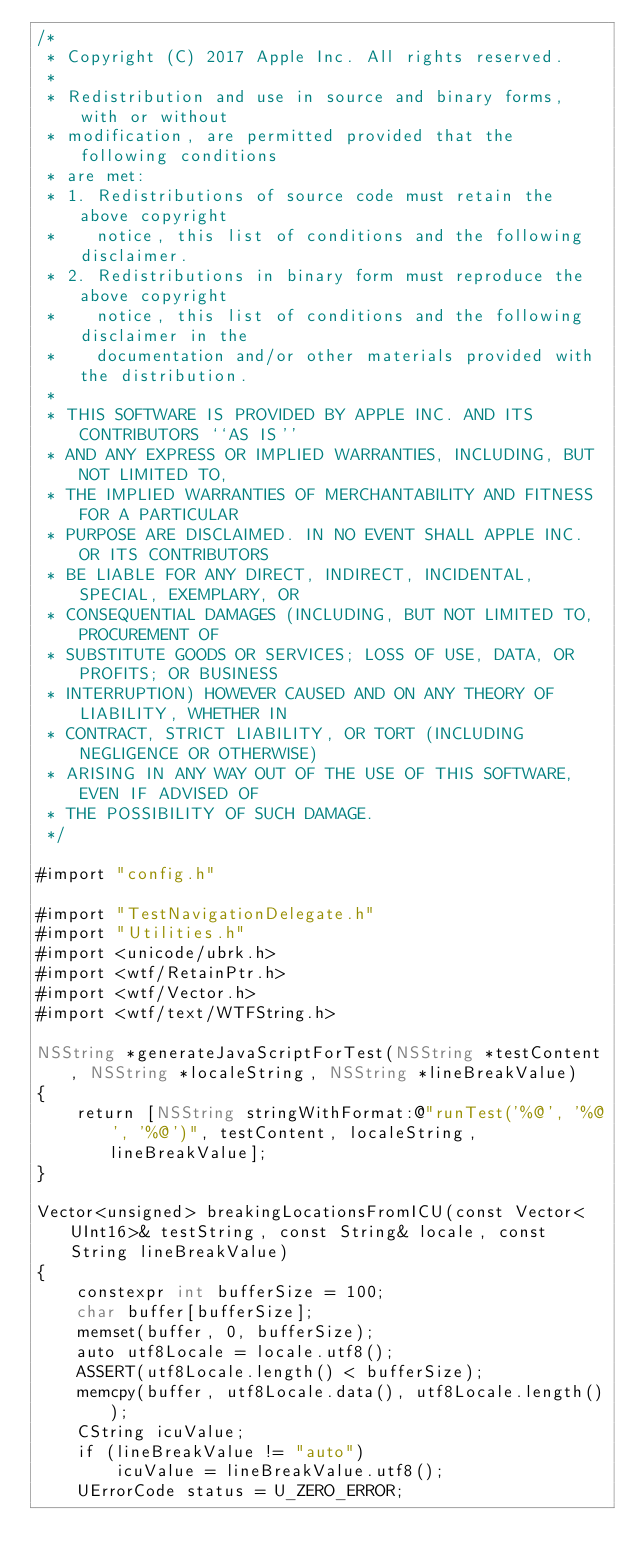<code> <loc_0><loc_0><loc_500><loc_500><_ObjectiveC_>/*
 * Copyright (C) 2017 Apple Inc. All rights reserved.
 *
 * Redistribution and use in source and binary forms, with or without
 * modification, are permitted provided that the following conditions
 * are met:
 * 1. Redistributions of source code must retain the above copyright
 *    notice, this list of conditions and the following disclaimer.
 * 2. Redistributions in binary form must reproduce the above copyright
 *    notice, this list of conditions and the following disclaimer in the
 *    documentation and/or other materials provided with the distribution.
 *
 * THIS SOFTWARE IS PROVIDED BY APPLE INC. AND ITS CONTRIBUTORS ``AS IS''
 * AND ANY EXPRESS OR IMPLIED WARRANTIES, INCLUDING, BUT NOT LIMITED TO,
 * THE IMPLIED WARRANTIES OF MERCHANTABILITY AND FITNESS FOR A PARTICULAR
 * PURPOSE ARE DISCLAIMED. IN NO EVENT SHALL APPLE INC. OR ITS CONTRIBUTORS
 * BE LIABLE FOR ANY DIRECT, INDIRECT, INCIDENTAL, SPECIAL, EXEMPLARY, OR
 * CONSEQUENTIAL DAMAGES (INCLUDING, BUT NOT LIMITED TO, PROCUREMENT OF
 * SUBSTITUTE GOODS OR SERVICES; LOSS OF USE, DATA, OR PROFITS; OR BUSINESS
 * INTERRUPTION) HOWEVER CAUSED AND ON ANY THEORY OF LIABILITY, WHETHER IN
 * CONTRACT, STRICT LIABILITY, OR TORT (INCLUDING NEGLIGENCE OR OTHERWISE)
 * ARISING IN ANY WAY OUT OF THE USE OF THIS SOFTWARE, EVEN IF ADVISED OF
 * THE POSSIBILITY OF SUCH DAMAGE.
 */

#import "config.h"

#import "TestNavigationDelegate.h"
#import "Utilities.h"
#import <unicode/ubrk.h>
#import <wtf/RetainPtr.h>
#import <wtf/Vector.h>
#import <wtf/text/WTFString.h>

NSString *generateJavaScriptForTest(NSString *testContent, NSString *localeString, NSString *lineBreakValue)
{
    return [NSString stringWithFormat:@"runTest('%@', '%@', '%@')", testContent, localeString, lineBreakValue];
}

Vector<unsigned> breakingLocationsFromICU(const Vector<UInt16>& testString, const String& locale, const String lineBreakValue)
{
    constexpr int bufferSize = 100;
    char buffer[bufferSize];
    memset(buffer, 0, bufferSize);
    auto utf8Locale = locale.utf8();
    ASSERT(utf8Locale.length() < bufferSize);
    memcpy(buffer, utf8Locale.data(), utf8Locale.length());
    CString icuValue;
    if (lineBreakValue != "auto")
        icuValue = lineBreakValue.utf8();
    UErrorCode status = U_ZERO_ERROR;</code> 